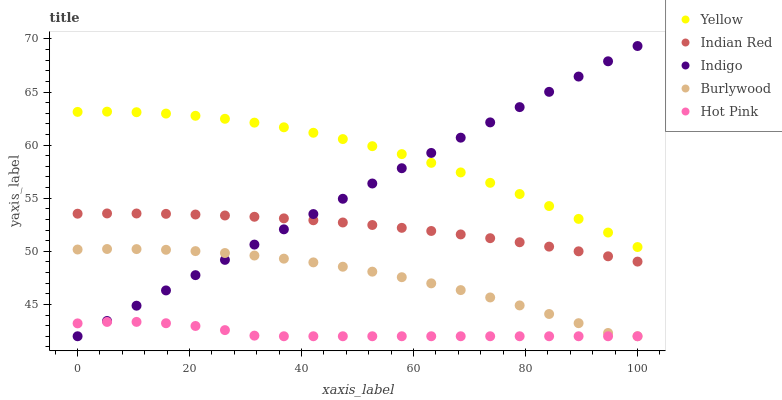Does Hot Pink have the minimum area under the curve?
Answer yes or no. Yes. Does Yellow have the maximum area under the curve?
Answer yes or no. Yes. Does Indigo have the minimum area under the curve?
Answer yes or no. No. Does Indigo have the maximum area under the curve?
Answer yes or no. No. Is Indigo the smoothest?
Answer yes or no. Yes. Is Burlywood the roughest?
Answer yes or no. Yes. Is Hot Pink the smoothest?
Answer yes or no. No. Is Hot Pink the roughest?
Answer yes or no. No. Does Burlywood have the lowest value?
Answer yes or no. Yes. Does Indian Red have the lowest value?
Answer yes or no. No. Does Indigo have the highest value?
Answer yes or no. Yes. Does Hot Pink have the highest value?
Answer yes or no. No. Is Hot Pink less than Yellow?
Answer yes or no. Yes. Is Indian Red greater than Burlywood?
Answer yes or no. Yes. Does Indigo intersect Hot Pink?
Answer yes or no. Yes. Is Indigo less than Hot Pink?
Answer yes or no. No. Is Indigo greater than Hot Pink?
Answer yes or no. No. Does Hot Pink intersect Yellow?
Answer yes or no. No. 